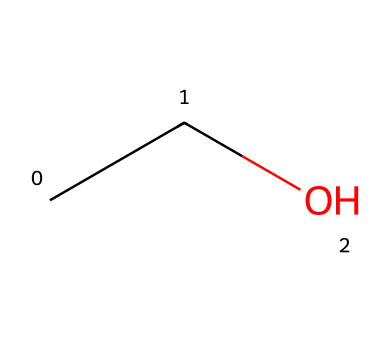What is the molecular formula of this chemical? The SMILES representation "CCO" indicates that there are 2 carbon atoms (C), 6 hydrogen atoms (H), and 1 oxygen atom (O), leading to the formula C2H6O.
Answer: C2H6O How many hydrogen atoms are present in the structure? The SMILES representation shows that there are 6 hydrogen atoms bonded to the 2 carbon atoms and 1 oxygen atom, giving a total of 6 H atoms.
Answer: 6 What type of functional group does this chemical contain? In the structure represented by "CCO", the presence of the "-OH" group (attached to a carbon) indicates that this chemical contains a hydroxyl functional group, characteristic of alcohols.
Answer: hydroxyl Is this chemical a monomer, dimer, or polymer? The chemical structure shown in the SMILES "CCO" is a simple molecule with minimal connectivity, indicating it is a monomer as it is not made up of repeating units like in dimers or polymers.
Answer: monomer What type of isomerism can this compound exhibit? The compound can exhibit structural isomerism due to the different arrangements it can have, specifically by having different connectivity of atoms, such as ethanal or dimethyl ether.
Answer: structural isomerism What is the primary type of bonding present in this compound? In the compound represented by "CCO", the atoms are held together primarily by covalent bonds, which involve sharing electrons between atoms, due to the nature of carbon, hydrogen, and oxygen.
Answer: covalent bonds 